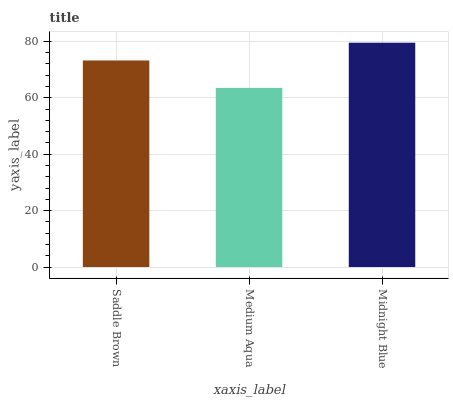Is Midnight Blue the minimum?
Answer yes or no. No. Is Medium Aqua the maximum?
Answer yes or no. No. Is Midnight Blue greater than Medium Aqua?
Answer yes or no. Yes. Is Medium Aqua less than Midnight Blue?
Answer yes or no. Yes. Is Medium Aqua greater than Midnight Blue?
Answer yes or no. No. Is Midnight Blue less than Medium Aqua?
Answer yes or no. No. Is Saddle Brown the high median?
Answer yes or no. Yes. Is Saddle Brown the low median?
Answer yes or no. Yes. Is Midnight Blue the high median?
Answer yes or no. No. Is Midnight Blue the low median?
Answer yes or no. No. 